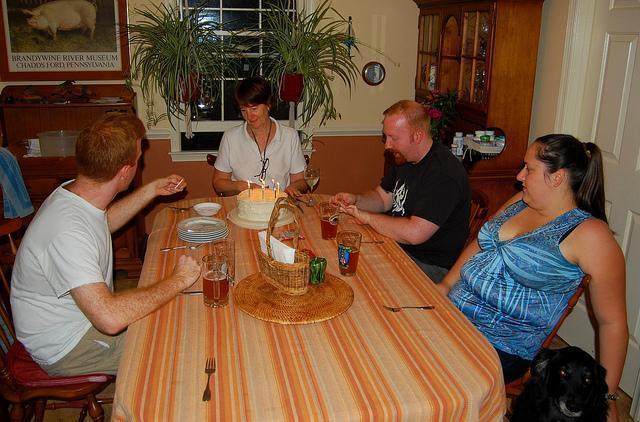Why are there candles in the cake in front of the woman?
From the following set of four choices, select the accurate answer to respond to the question.
Options: For light, her graduation, her birthday, decoration. Her birthday. 